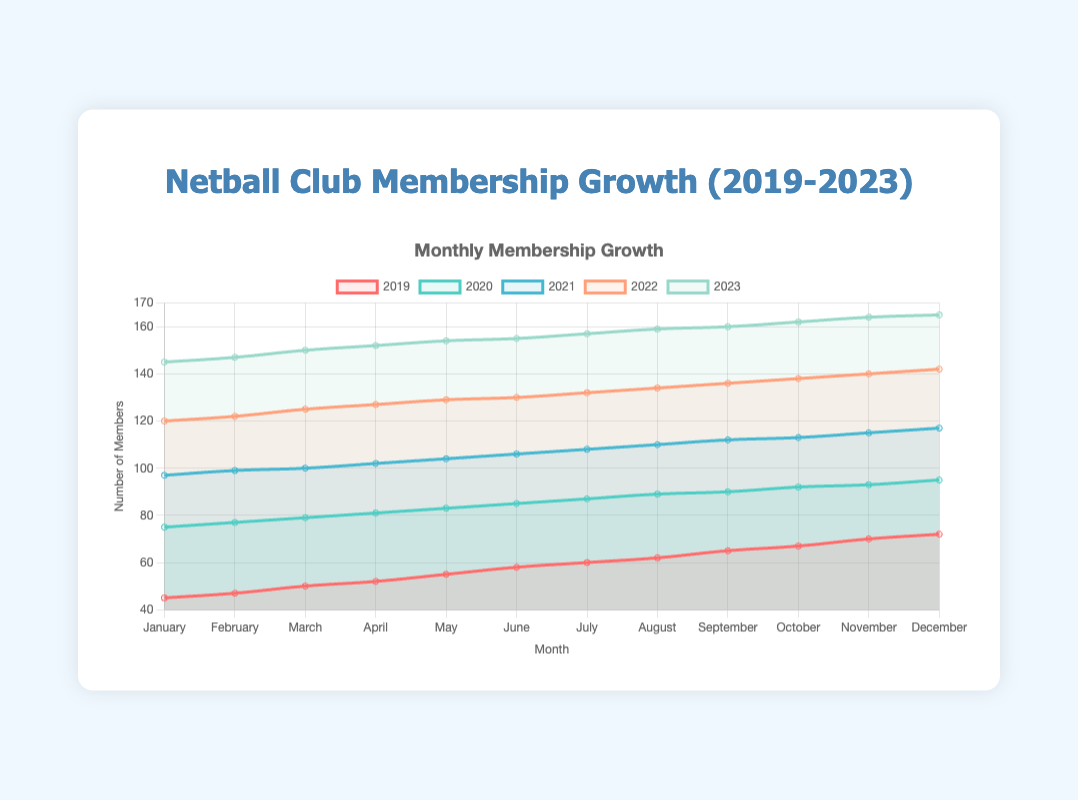What is the maximum number of members in any month in 2023? According to the line for the year 2023, the highest value of membership in any given month is reached in December with 165 members.
Answer: 165 How many new members did the club gain from January to December 2020? From January 2020 (75 members) to December 2020 (95 members), the increase in membership is 95 - 75 = 20.
Answer: 20 Which year had the highest rate of membership growth between January and December? The year 2022 shows the highest increase in membership, starting at 120 members in January and reaching 142 by December, a total increase of 22 members.
Answer: 2022 Which year exhibited the least increase in membership numbers in any month? To determine the year with the least increase in any month, compare the monthly steps. Observation shows that 2023 has the least monthly increments, as depicted by its relatively flatter slope compared to other years.
Answer: 2023 During which month did each year seem to have the most significant jump in memberships from preceding month? By viewing the graph's upward spike relative to previous months for each line, in April for most years (like 2020, 2021, and 2023), it has a steep increase consistently across the years.
Answer: April 